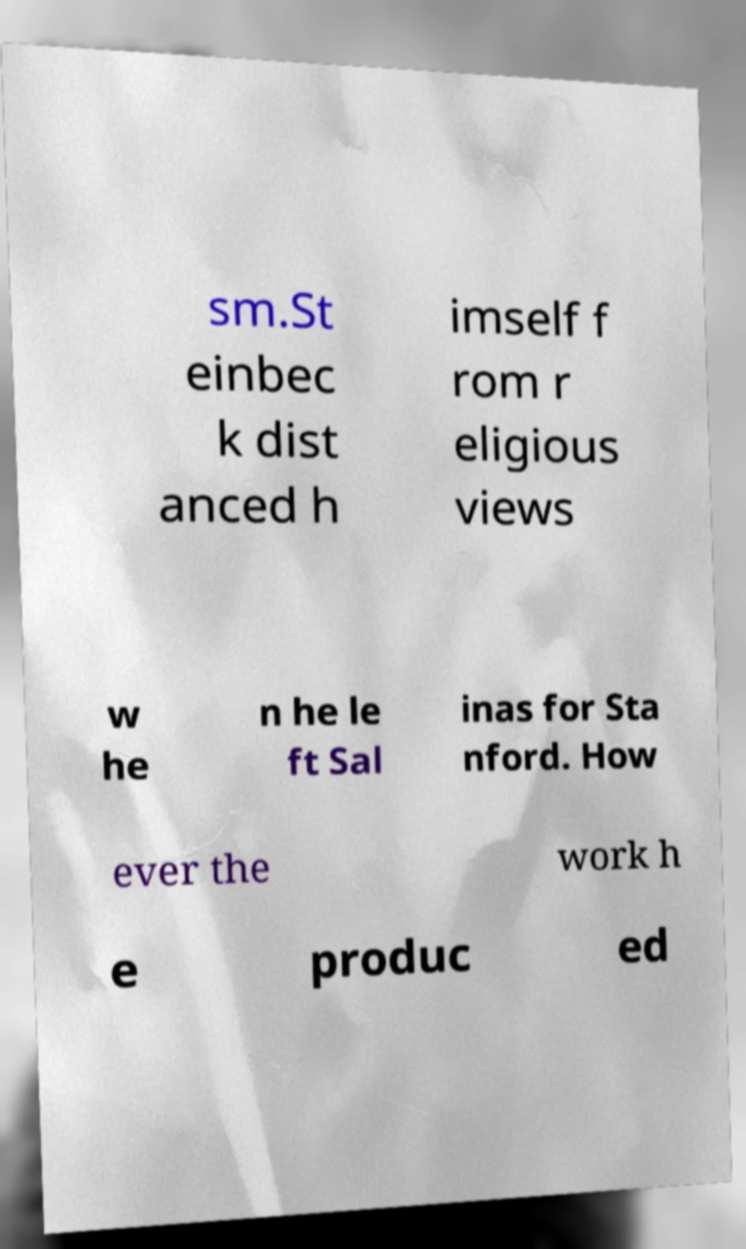Could you extract and type out the text from this image? sm.St einbec k dist anced h imself f rom r eligious views w he n he le ft Sal inas for Sta nford. How ever the work h e produc ed 